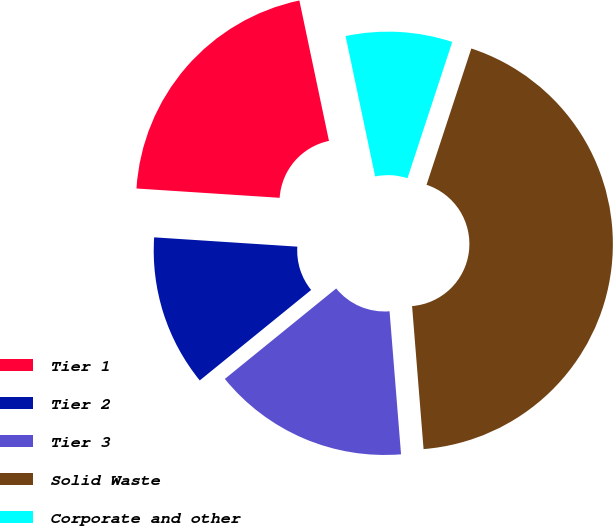Convert chart. <chart><loc_0><loc_0><loc_500><loc_500><pie_chart><fcel>Tier 1<fcel>Tier 2<fcel>Tier 3<fcel>Solid Waste<fcel>Corporate and other<nl><fcel>20.66%<fcel>11.89%<fcel>15.42%<fcel>43.67%<fcel>8.36%<nl></chart> 